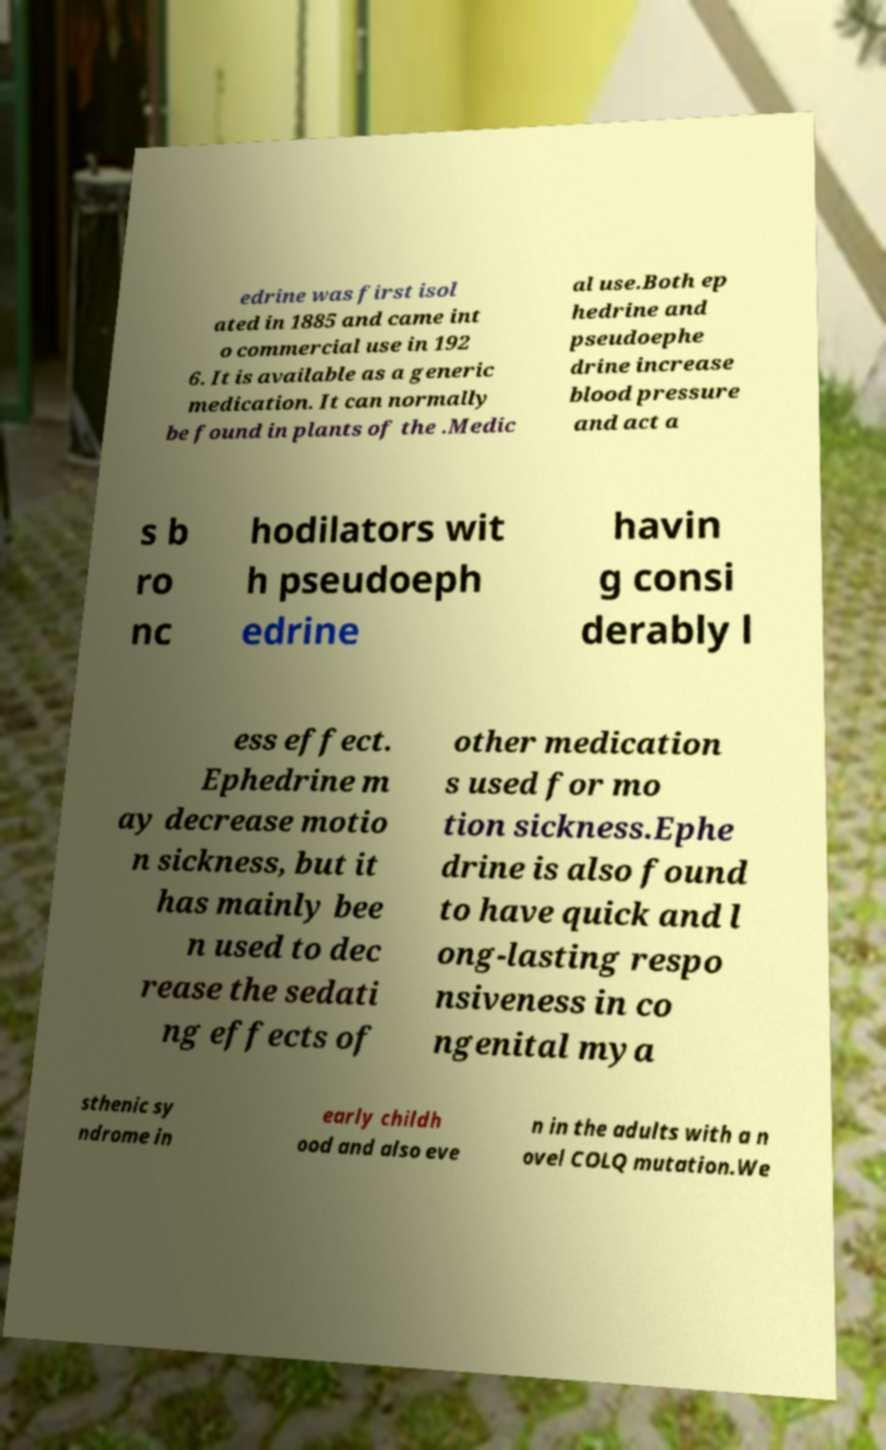What messages or text are displayed in this image? I need them in a readable, typed format. edrine was first isol ated in 1885 and came int o commercial use in 192 6. It is available as a generic medication. It can normally be found in plants of the .Medic al use.Both ep hedrine and pseudoephe drine increase blood pressure and act a s b ro nc hodilators wit h pseudoeph edrine havin g consi derably l ess effect. Ephedrine m ay decrease motio n sickness, but it has mainly bee n used to dec rease the sedati ng effects of other medication s used for mo tion sickness.Ephe drine is also found to have quick and l ong-lasting respo nsiveness in co ngenital mya sthenic sy ndrome in early childh ood and also eve n in the adults with a n ovel COLQ mutation.We 